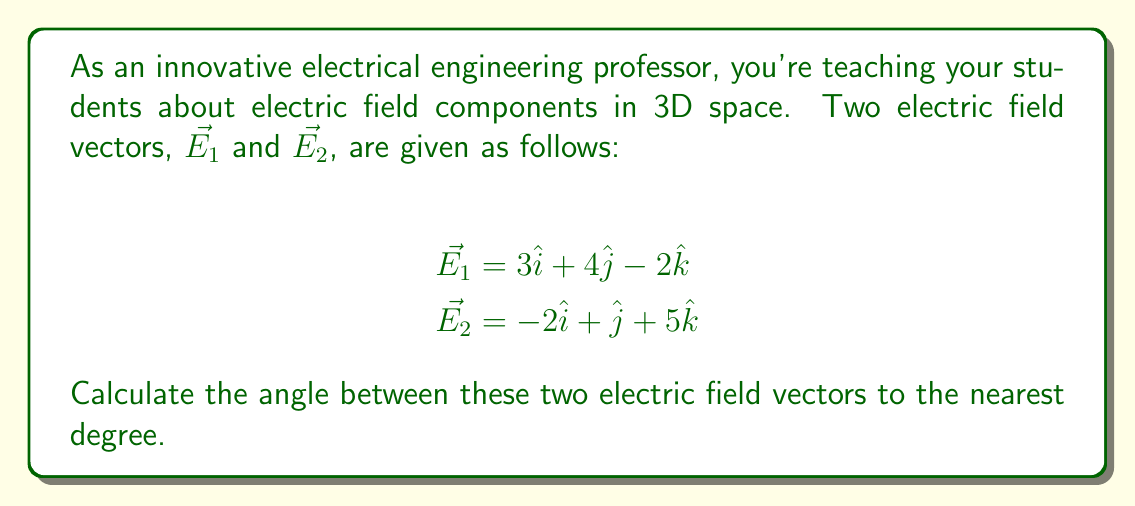Could you help me with this problem? To find the angle between two vectors in 3D space, we can use the dot product formula:

$$\cos \theta = \frac{\vec{E_1} \cdot \vec{E_2}}{|\vec{E_1}||\vec{E_2}|}$$

Let's solve this step-by-step:

1) First, calculate the dot product $\vec{E_1} \cdot \vec{E_2}$:
   $$\vec{E_1} \cdot \vec{E_2} = (3)(-2) + (4)(1) + (-2)(5) = -6 + 4 - 10 = -12$$

2) Next, calculate the magnitudes of both vectors:
   $$|\vec{E_1}| = \sqrt{3^2 + 4^2 + (-2)^2} = \sqrt{9 + 16 + 4} = \sqrt{29}$$
   $$|\vec{E_2}| = \sqrt{(-2)^2 + 1^2 + 5^2} = \sqrt{4 + 1 + 25} = \sqrt{30}$$

3) Now, substitute these values into the dot product formula:
   $$\cos \theta = \frac{-12}{\sqrt{29}\sqrt{30}}$$

4) Simplify:
   $$\cos \theta = \frac{-12}{\sqrt{870}}$$

5) To find $\theta$, take the inverse cosine (arccos) of both sides:
   $$\theta = \arccos\left(\frac{-12}{\sqrt{870}}\right)$$

6) Using a calculator and rounding to the nearest degree:
   $$\theta \approx 102°$$
Answer: The angle between the two electric field vectors is approximately 102°. 